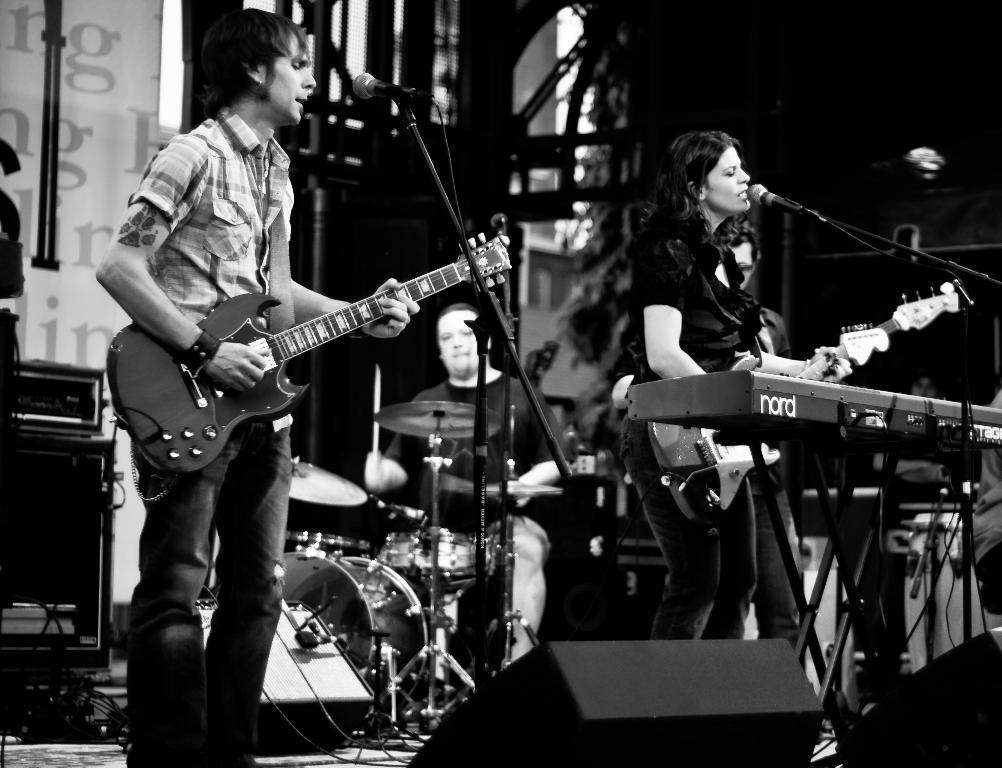Can you describe this image briefly? In this image i can see a man wearing a shirt and a pant standing and holding a guitar, I can see a microphone in front of him. To the right of the image i can see a woman standing and holding a guitar in her hand, i can see a microphone in front of her. In the background i can see another person sitting in front of musical instruments. 